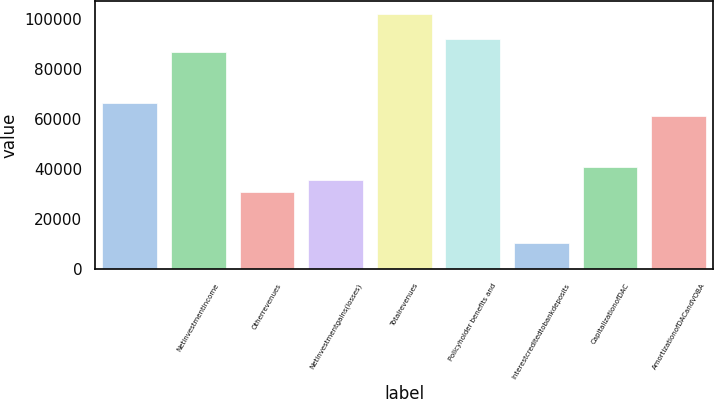Convert chart. <chart><loc_0><loc_0><loc_500><loc_500><bar_chart><ecel><fcel>Netinvestmentincome<fcel>Otherrevenues<fcel>Netinvestmentgains(losses)<fcel>Totalrevenues<fcel>Policyholder benefits and<fcel>Interestcreditedtobankdeposits<fcel>CapitalizationofDAC<fcel>AmortizationofDACandVOBA<nl><fcel>66258.5<fcel>86624.5<fcel>30618<fcel>35709.5<fcel>101899<fcel>91716<fcel>10252<fcel>40801<fcel>61167<nl></chart> 